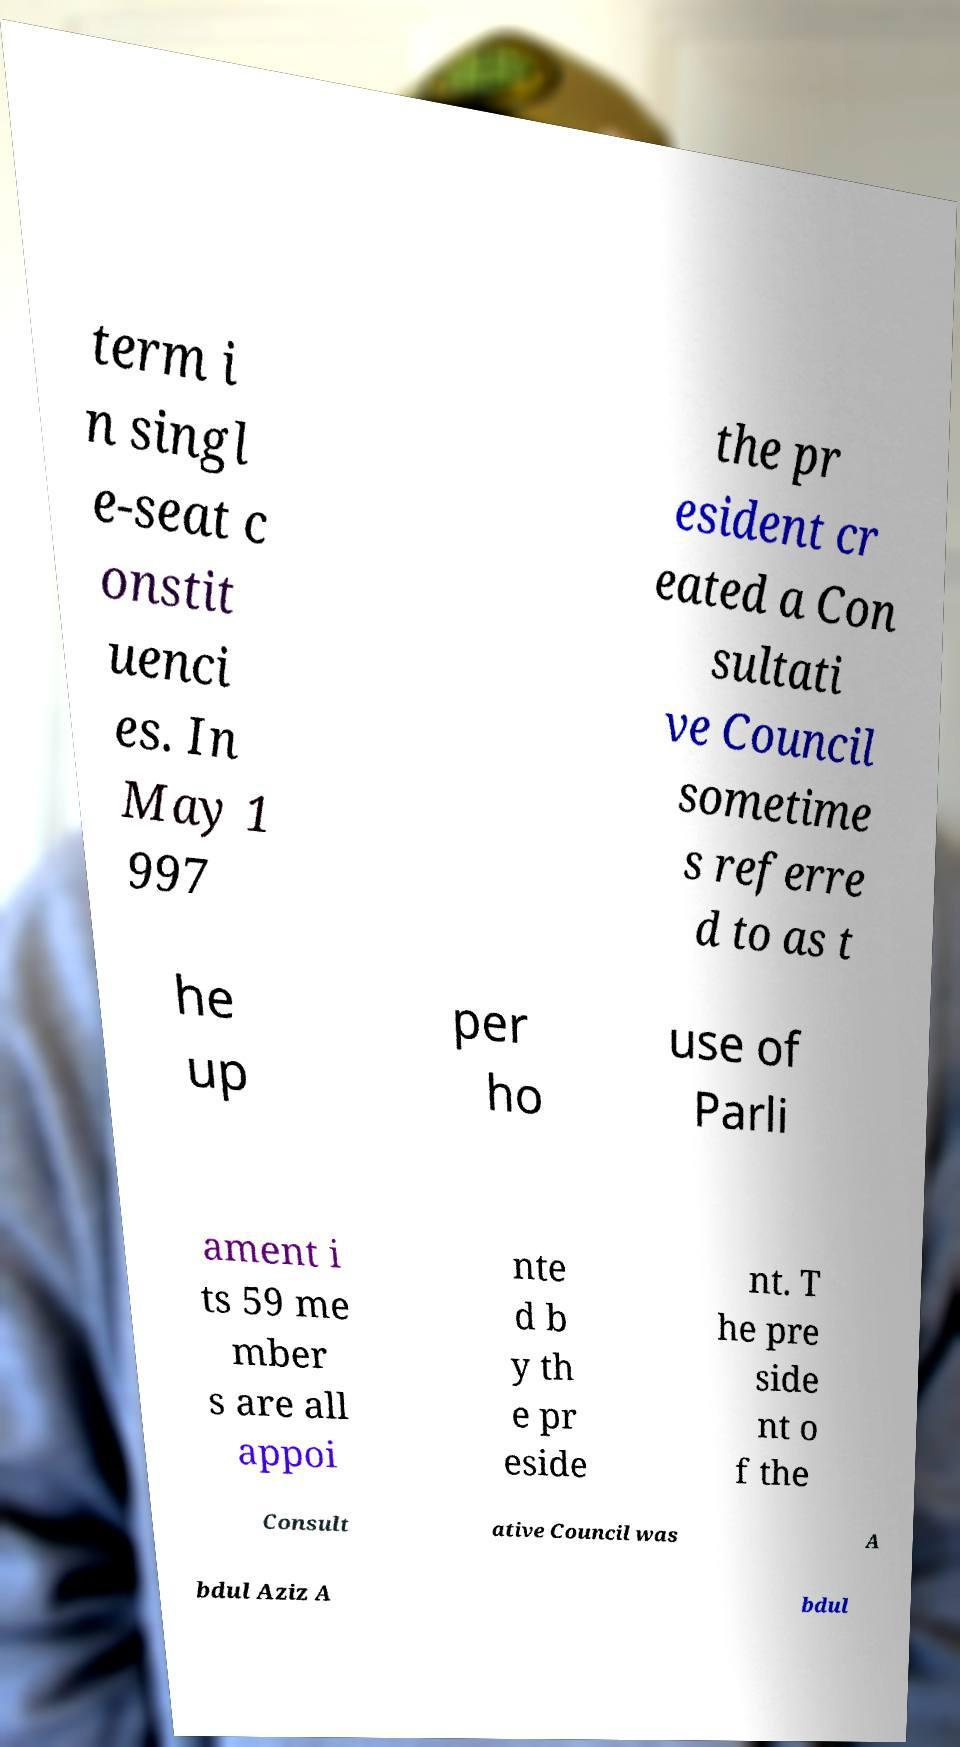Please identify and transcribe the text found in this image. term i n singl e-seat c onstit uenci es. In May 1 997 the pr esident cr eated a Con sultati ve Council sometime s referre d to as t he up per ho use of Parli ament i ts 59 me mber s are all appoi nte d b y th e pr eside nt. T he pre side nt o f the Consult ative Council was A bdul Aziz A bdul 